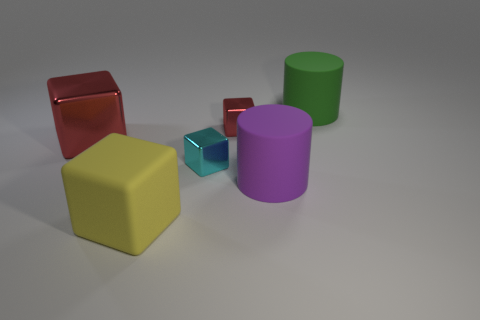Is the color of the large cube that is behind the large purple thing the same as the small block behind the large red shiny object?
Offer a very short reply. Yes. How many rubber objects are to the left of the purple rubber thing and behind the big yellow thing?
Keep it short and to the point. 0. How many other things are the same shape as the purple matte thing?
Offer a very short reply. 1. Is the number of matte cylinders that are in front of the cyan block greater than the number of tiny brown cylinders?
Make the answer very short. Yes. What is the color of the big rubber object right of the purple matte cylinder?
Your response must be concise. Green. What number of matte objects are either large red cubes or red cubes?
Your response must be concise. 0. Is there a cyan thing left of the large cylinder to the left of the large matte cylinder that is on the right side of the big purple matte object?
Provide a succinct answer. Yes. There is a green cylinder; what number of rubber things are on the left side of it?
Your response must be concise. 2. How many tiny objects are either yellow blocks or green rubber cylinders?
Your response must be concise. 0. There is a purple thing in front of the large green cylinder; what is its shape?
Offer a very short reply. Cylinder. 